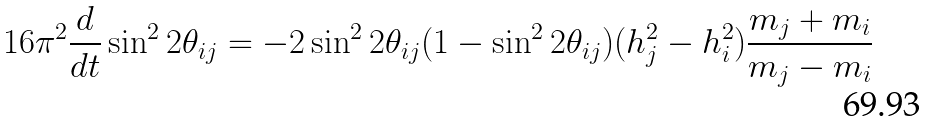Convert formula to latex. <formula><loc_0><loc_0><loc_500><loc_500>1 6 \pi ^ { 2 } \frac { d } { d t } \sin ^ { 2 } 2 \theta _ { i j } = - 2 \sin ^ { 2 } 2 \theta _ { i j } ( 1 - \sin ^ { 2 } 2 \theta _ { i j } ) ( h _ { j } ^ { 2 } - h _ { i } ^ { 2 } ) \frac { m _ { j } + m _ { i } } { m _ { j } - m _ { i } }</formula> 